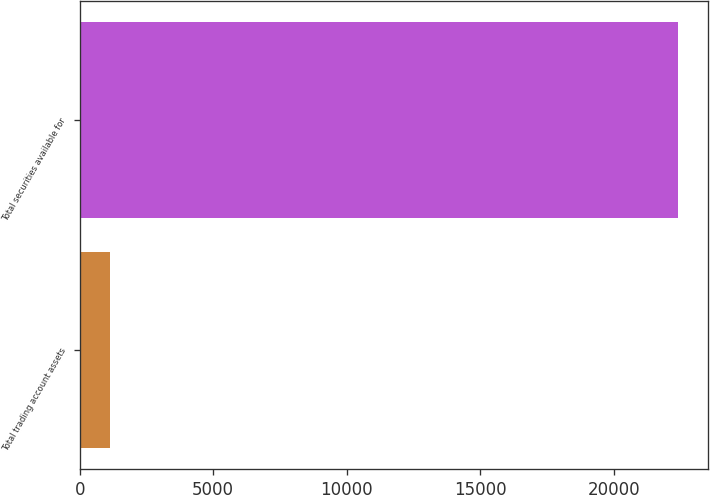Convert chart to OTSL. <chart><loc_0><loc_0><loc_500><loc_500><bar_chart><fcel>Total trading account assets<fcel>Total securities available for<nl><fcel>1116<fcel>22399<nl></chart> 